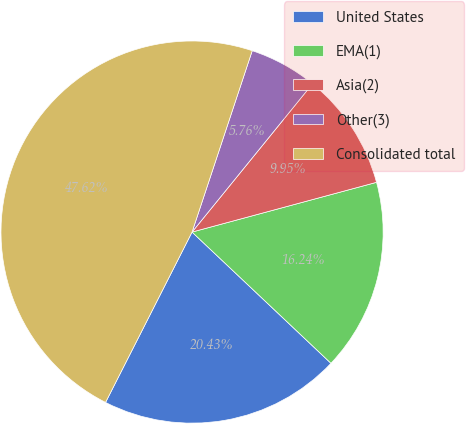Convert chart to OTSL. <chart><loc_0><loc_0><loc_500><loc_500><pie_chart><fcel>United States<fcel>EMA(1)<fcel>Asia(2)<fcel>Other(3)<fcel>Consolidated total<nl><fcel>20.43%<fcel>16.24%<fcel>9.95%<fcel>5.76%<fcel>47.62%<nl></chart> 